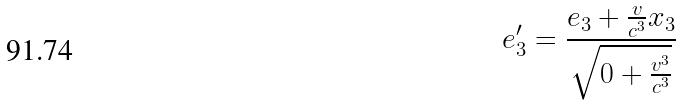<formula> <loc_0><loc_0><loc_500><loc_500>e _ { 3 } ^ { \prime } = \frac { e _ { 3 } + \frac { v } { c ^ { 3 } } x _ { 3 } } { \sqrt { 0 + \frac { v ^ { 3 } } { c ^ { 3 } } } }</formula> 